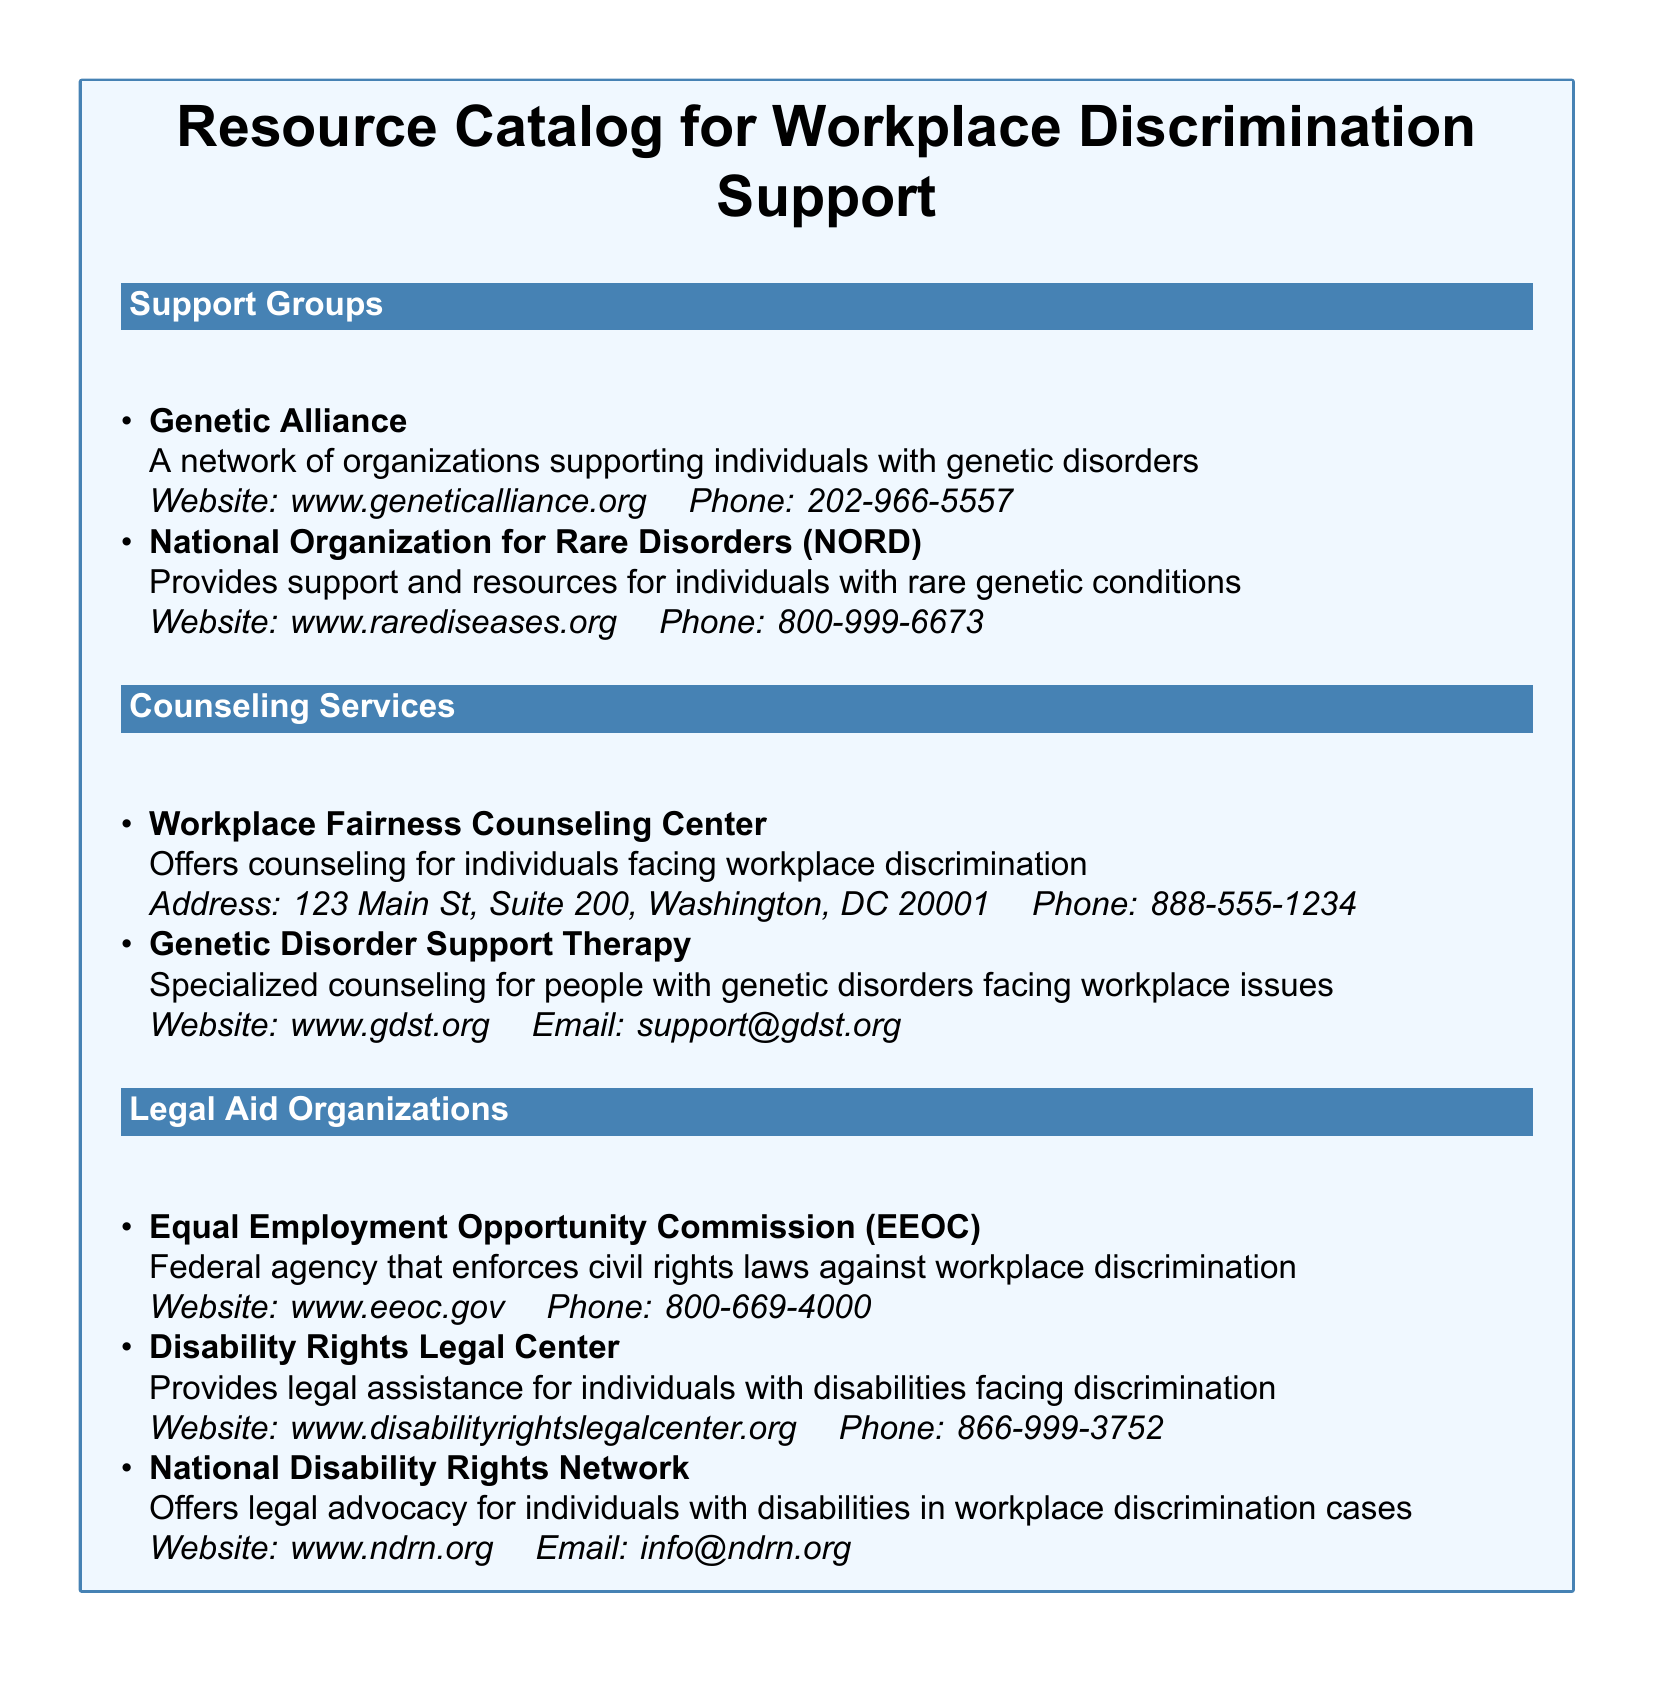What is the website for Genetic Alliance? The website for Genetic Alliance is listed in the document under Support Groups section.
Answer: www.geneticalliance.org How many support groups are listed? The document includes a total of two support groups under the Support Groups section.
Answer: 2 What service does the Genetic Disorder Support Therapy provide? This service is specialized counseling for people with genetic disorders facing workplace issues, as stated in the Counseling Services section.
Answer: Specialized counseling What is the phone number for the Equal Employment Opportunity Commission? The phone number is provided in the Legal Aid Organizations section alongside the organization name.
Answer: 800-669-4000 Which organization offers counseling for individuals facing workplace discrimination? The document specifies Workplace Fairness Counseling Center as a service offering counseling for workplace discrimination.
Answer: Workplace Fairness Counseling Center How can you contact the National Disability Rights Network? The contact information includes an email provided in the document, which indicates the way to reach out.
Answer: info@ndrn.org What is the main focus of the National Organization for Rare Disorders (NORD)? This organization provides support and resources for individuals with rare genetic conditions, as detailed in the Support Groups section.
Answer: Support and resources for rare genetic conditions What is the phone number for Disability Rights Legal Center? The phone number is included with the organization's details in the Legal Aid Organizations section.
Answer: 866-999-3752 